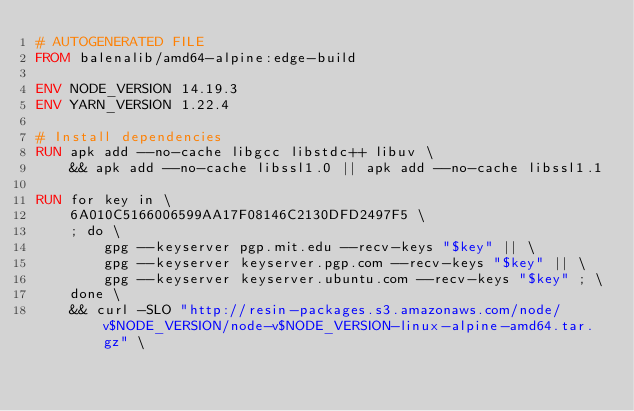Convert code to text. <code><loc_0><loc_0><loc_500><loc_500><_Dockerfile_># AUTOGENERATED FILE
FROM balenalib/amd64-alpine:edge-build

ENV NODE_VERSION 14.19.3
ENV YARN_VERSION 1.22.4

# Install dependencies
RUN apk add --no-cache libgcc libstdc++ libuv \
	&& apk add --no-cache libssl1.0 || apk add --no-cache libssl1.1

RUN for key in \
	6A010C5166006599AA17F08146C2130DFD2497F5 \
	; do \
		gpg --keyserver pgp.mit.edu --recv-keys "$key" || \
		gpg --keyserver keyserver.pgp.com --recv-keys "$key" || \
		gpg --keyserver keyserver.ubuntu.com --recv-keys "$key" ; \
	done \
	&& curl -SLO "http://resin-packages.s3.amazonaws.com/node/v$NODE_VERSION/node-v$NODE_VERSION-linux-alpine-amd64.tar.gz" \</code> 